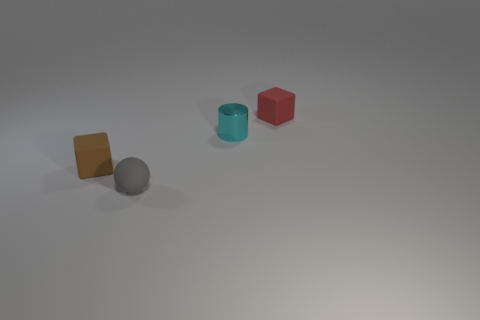Add 3 green matte cylinders. How many objects exist? 7 Subtract all cylinders. How many objects are left? 3 Subtract all tiny cyan cylinders. Subtract all small red metal cubes. How many objects are left? 3 Add 2 tiny cyan metal cylinders. How many tiny cyan metal cylinders are left? 3 Add 3 small cyan objects. How many small cyan objects exist? 4 Subtract 0 purple blocks. How many objects are left? 4 